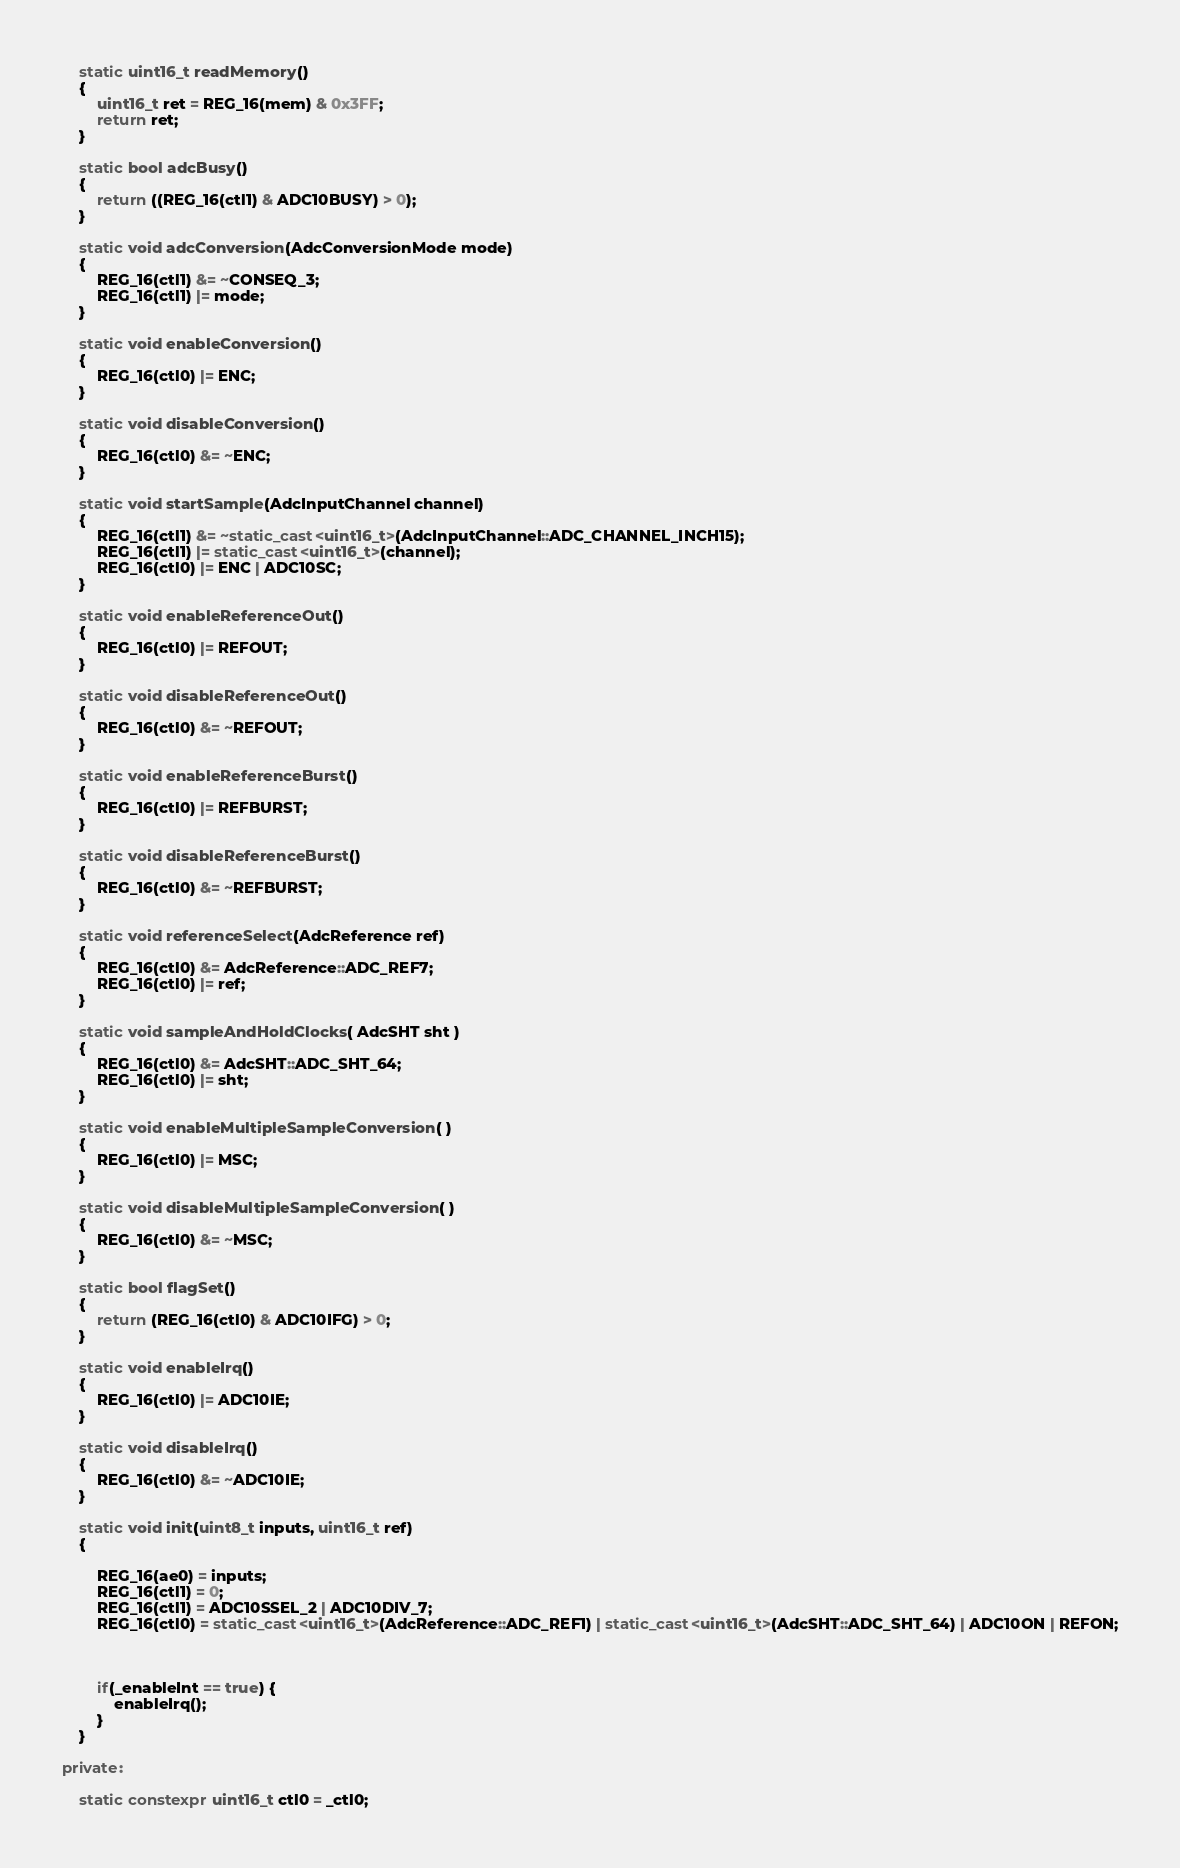<code> <loc_0><loc_0><loc_500><loc_500><_C++_>

	static uint16_t readMemory()
	{
		uint16_t ret = REG_16(mem) & 0x3FF;
		return ret;
	}

	static bool adcBusy()
	{
		return ((REG_16(ctl1) & ADC10BUSY) > 0);
	}

	static void adcConversion(AdcConversionMode mode)
	{
		REG_16(ctl1) &= ~CONSEQ_3;
		REG_16(ctl1) |= mode;
	}

	static void enableConversion()
	{
		REG_16(ctl0) |= ENC;
	}

	static void disableConversion()
	{
		REG_16(ctl0) &= ~ENC;
	}

	static void startSample(AdcInputChannel channel)
	{
		REG_16(ctl1) &= ~static_cast<uint16_t>(AdcInputChannel::ADC_CHANNEL_INCH15);
		REG_16(ctl1) |= static_cast<uint16_t>(channel);
		REG_16(ctl0) |= ENC | ADC10SC;
	}

	static void enableReferenceOut()
	{
		REG_16(ctl0) |= REFOUT;
	}

	static void disableReferenceOut()
	{
		REG_16(ctl0) &= ~REFOUT;
	}

	static void enableReferenceBurst()
	{
		REG_16(ctl0) |= REFBURST;
	}

	static void disableReferenceBurst()
	{
		REG_16(ctl0) &= ~REFBURST;
	}

	static void referenceSelect(AdcReference ref)
	{
		REG_16(ctl0) &= AdcReference::ADC_REF7;
		REG_16(ctl0) |= ref;
	}

	static void sampleAndHoldClocks( AdcSHT sht )
	{
		REG_16(ctl0) &= AdcSHT::ADC_SHT_64;
		REG_16(ctl0) |= sht;
	}

	static void enableMultipleSampleConversion( )
	{
		REG_16(ctl0) |= MSC;
	}

	static void disableMultipleSampleConversion( )
	{
		REG_16(ctl0) &= ~MSC;
	}

	static bool flagSet()
	{
		return (REG_16(ctl0) & ADC10IFG) > 0;
	}

	static void enableIrq()
	{
		REG_16(ctl0) |= ADC10IE;
	}

	static void disableIrq()
	{
		REG_16(ctl0) &= ~ADC10IE;
	}

	static void init(uint8_t inputs, uint16_t ref)
	{

		REG_16(ae0) = inputs;
		REG_16(ctl1) = 0;
		REG_16(ctl1) = ADC10SSEL_2 | ADC10DIV_7;
		REG_16(ctl0) = static_cast<uint16_t>(AdcReference::ADC_REF1) | static_cast<uint16_t>(AdcSHT::ADC_SHT_64) | ADC10ON | REFON;



		if(_enableInt == true) {
			enableIrq();
		}
	}

private:

	static constexpr uint16_t ctl0 = _ctl0;</code> 